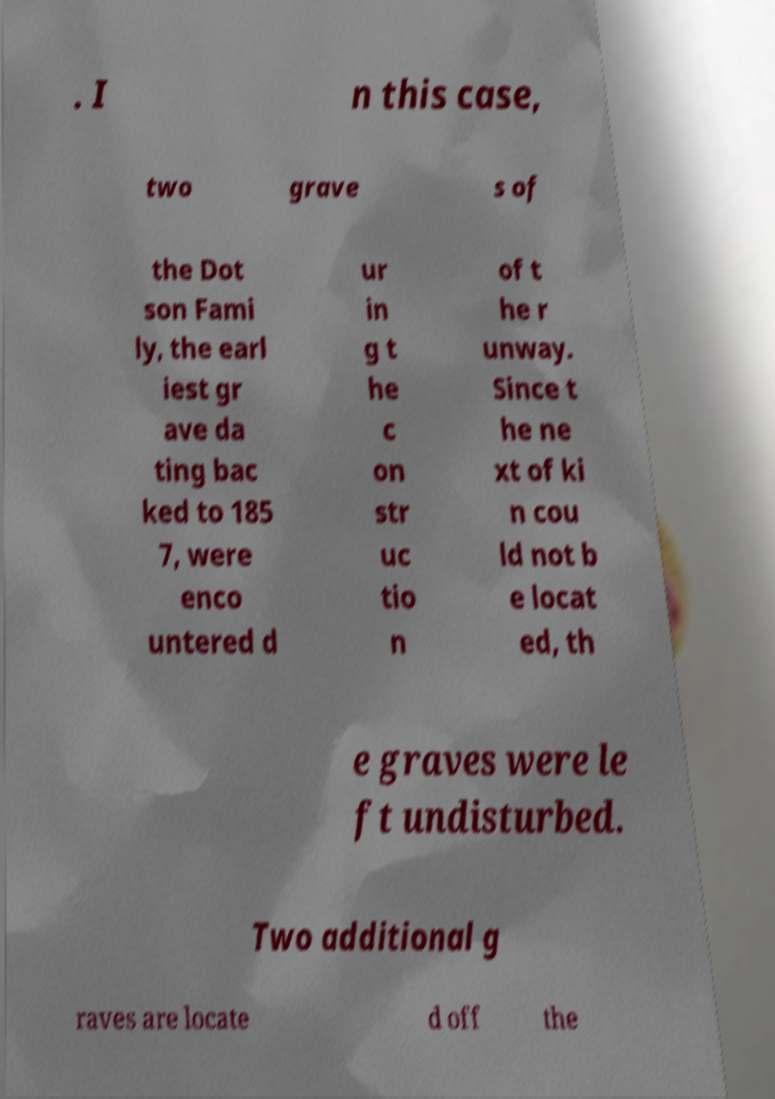Could you assist in decoding the text presented in this image and type it out clearly? . I n this case, two grave s of the Dot son Fami ly, the earl iest gr ave da ting bac ked to 185 7, were enco untered d ur in g t he c on str uc tio n of t he r unway. Since t he ne xt of ki n cou ld not b e locat ed, th e graves were le ft undisturbed. Two additional g raves are locate d off the 